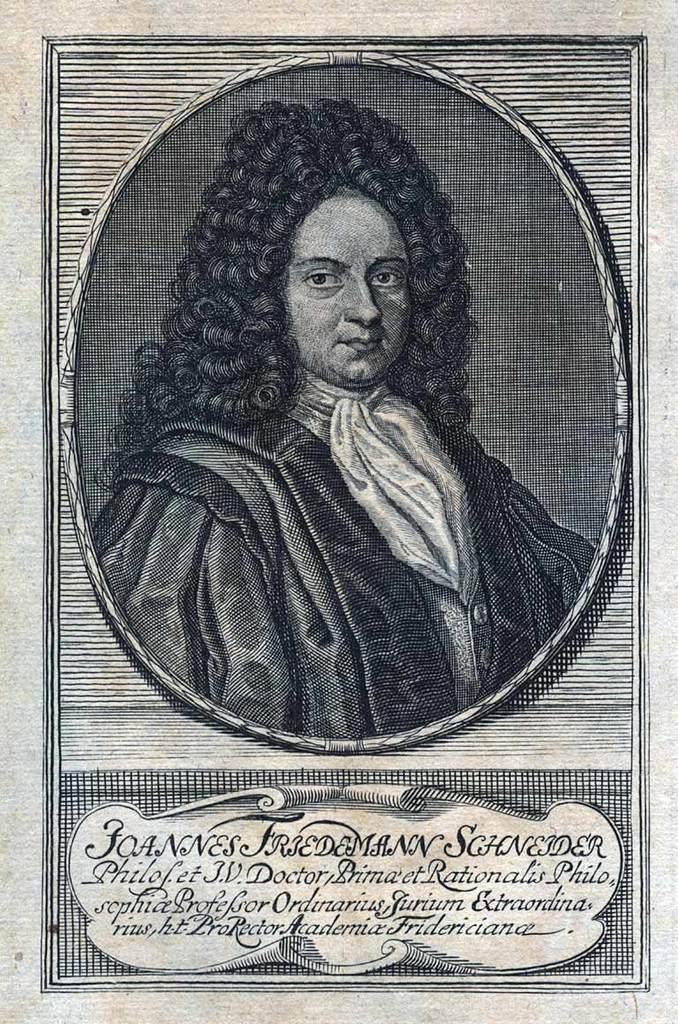What's the last name of this guy?
Keep it short and to the point. Schneider. 